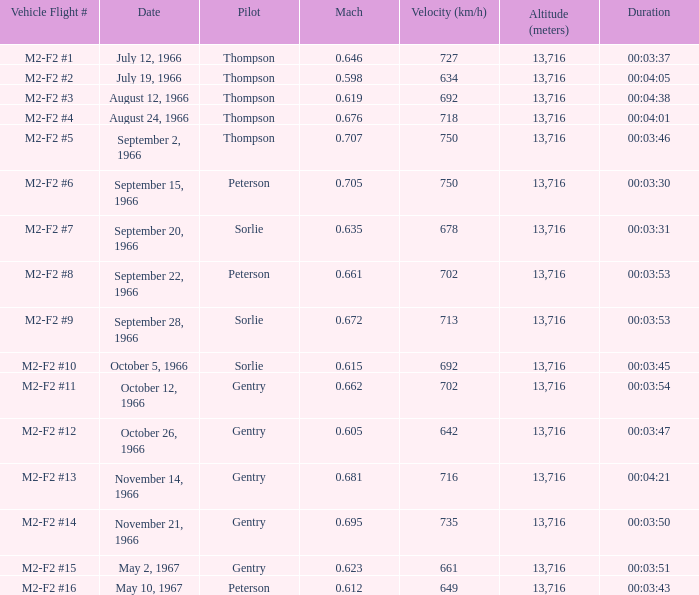What date possesses a mach of October 12, 1966. 